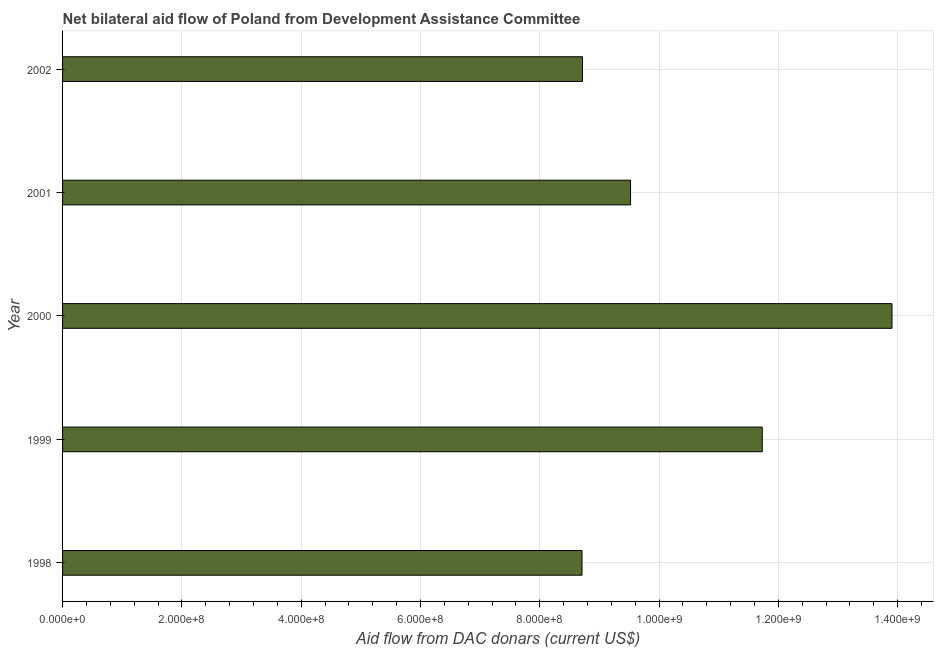Does the graph contain any zero values?
Keep it short and to the point. No. What is the title of the graph?
Keep it short and to the point. Net bilateral aid flow of Poland from Development Assistance Committee. What is the label or title of the X-axis?
Give a very brief answer. Aid flow from DAC donars (current US$). What is the label or title of the Y-axis?
Your answer should be very brief. Year. What is the net bilateral aid flows from dac donors in 2002?
Your answer should be very brief. 8.72e+08. Across all years, what is the maximum net bilateral aid flows from dac donors?
Your response must be concise. 1.39e+09. Across all years, what is the minimum net bilateral aid flows from dac donors?
Your answer should be very brief. 8.71e+08. In which year was the net bilateral aid flows from dac donors minimum?
Give a very brief answer. 1998. What is the sum of the net bilateral aid flows from dac donors?
Your answer should be very brief. 5.26e+09. What is the difference between the net bilateral aid flows from dac donors in 2000 and 2002?
Your answer should be compact. 5.19e+08. What is the average net bilateral aid flows from dac donors per year?
Keep it short and to the point. 1.05e+09. What is the median net bilateral aid flows from dac donors?
Keep it short and to the point. 9.52e+08. Do a majority of the years between 1999 and 2001 (inclusive) have net bilateral aid flows from dac donors greater than 400000000 US$?
Give a very brief answer. Yes. What is the ratio of the net bilateral aid flows from dac donors in 2001 to that in 2002?
Provide a succinct answer. 1.09. Is the net bilateral aid flows from dac donors in 1999 less than that in 2000?
Offer a terse response. Yes. What is the difference between the highest and the second highest net bilateral aid flows from dac donors?
Make the answer very short. 2.18e+08. Is the sum of the net bilateral aid flows from dac donors in 1998 and 2000 greater than the maximum net bilateral aid flows from dac donors across all years?
Your answer should be very brief. Yes. What is the difference between the highest and the lowest net bilateral aid flows from dac donors?
Ensure brevity in your answer.  5.20e+08. In how many years, is the net bilateral aid flows from dac donors greater than the average net bilateral aid flows from dac donors taken over all years?
Keep it short and to the point. 2. How many bars are there?
Offer a terse response. 5. Are all the bars in the graph horizontal?
Keep it short and to the point. Yes. What is the difference between two consecutive major ticks on the X-axis?
Offer a terse response. 2.00e+08. Are the values on the major ticks of X-axis written in scientific E-notation?
Make the answer very short. Yes. What is the Aid flow from DAC donars (current US$) of 1998?
Your answer should be very brief. 8.71e+08. What is the Aid flow from DAC donars (current US$) of 1999?
Keep it short and to the point. 1.17e+09. What is the Aid flow from DAC donars (current US$) in 2000?
Ensure brevity in your answer.  1.39e+09. What is the Aid flow from DAC donars (current US$) of 2001?
Ensure brevity in your answer.  9.52e+08. What is the Aid flow from DAC donars (current US$) of 2002?
Your answer should be compact. 8.72e+08. What is the difference between the Aid flow from DAC donars (current US$) in 1998 and 1999?
Your answer should be very brief. -3.02e+08. What is the difference between the Aid flow from DAC donars (current US$) in 1998 and 2000?
Provide a short and direct response. -5.20e+08. What is the difference between the Aid flow from DAC donars (current US$) in 1998 and 2001?
Keep it short and to the point. -8.14e+07. What is the difference between the Aid flow from DAC donars (current US$) in 1998 and 2002?
Your response must be concise. -8.30e+05. What is the difference between the Aid flow from DAC donars (current US$) in 1999 and 2000?
Your answer should be very brief. -2.18e+08. What is the difference between the Aid flow from DAC donars (current US$) in 1999 and 2001?
Your answer should be very brief. 2.21e+08. What is the difference between the Aid flow from DAC donars (current US$) in 1999 and 2002?
Provide a short and direct response. 3.01e+08. What is the difference between the Aid flow from DAC donars (current US$) in 2000 and 2001?
Offer a terse response. 4.38e+08. What is the difference between the Aid flow from DAC donars (current US$) in 2000 and 2002?
Ensure brevity in your answer.  5.19e+08. What is the difference between the Aid flow from DAC donars (current US$) in 2001 and 2002?
Provide a short and direct response. 8.06e+07. What is the ratio of the Aid flow from DAC donars (current US$) in 1998 to that in 1999?
Keep it short and to the point. 0.74. What is the ratio of the Aid flow from DAC donars (current US$) in 1998 to that in 2000?
Offer a terse response. 0.63. What is the ratio of the Aid flow from DAC donars (current US$) in 1998 to that in 2001?
Provide a short and direct response. 0.92. What is the ratio of the Aid flow from DAC donars (current US$) in 1998 to that in 2002?
Offer a terse response. 1. What is the ratio of the Aid flow from DAC donars (current US$) in 1999 to that in 2000?
Provide a succinct answer. 0.84. What is the ratio of the Aid flow from DAC donars (current US$) in 1999 to that in 2001?
Your answer should be compact. 1.23. What is the ratio of the Aid flow from DAC donars (current US$) in 1999 to that in 2002?
Give a very brief answer. 1.35. What is the ratio of the Aid flow from DAC donars (current US$) in 2000 to that in 2001?
Your answer should be compact. 1.46. What is the ratio of the Aid flow from DAC donars (current US$) in 2000 to that in 2002?
Your answer should be very brief. 1.59. What is the ratio of the Aid flow from DAC donars (current US$) in 2001 to that in 2002?
Your answer should be very brief. 1.09. 